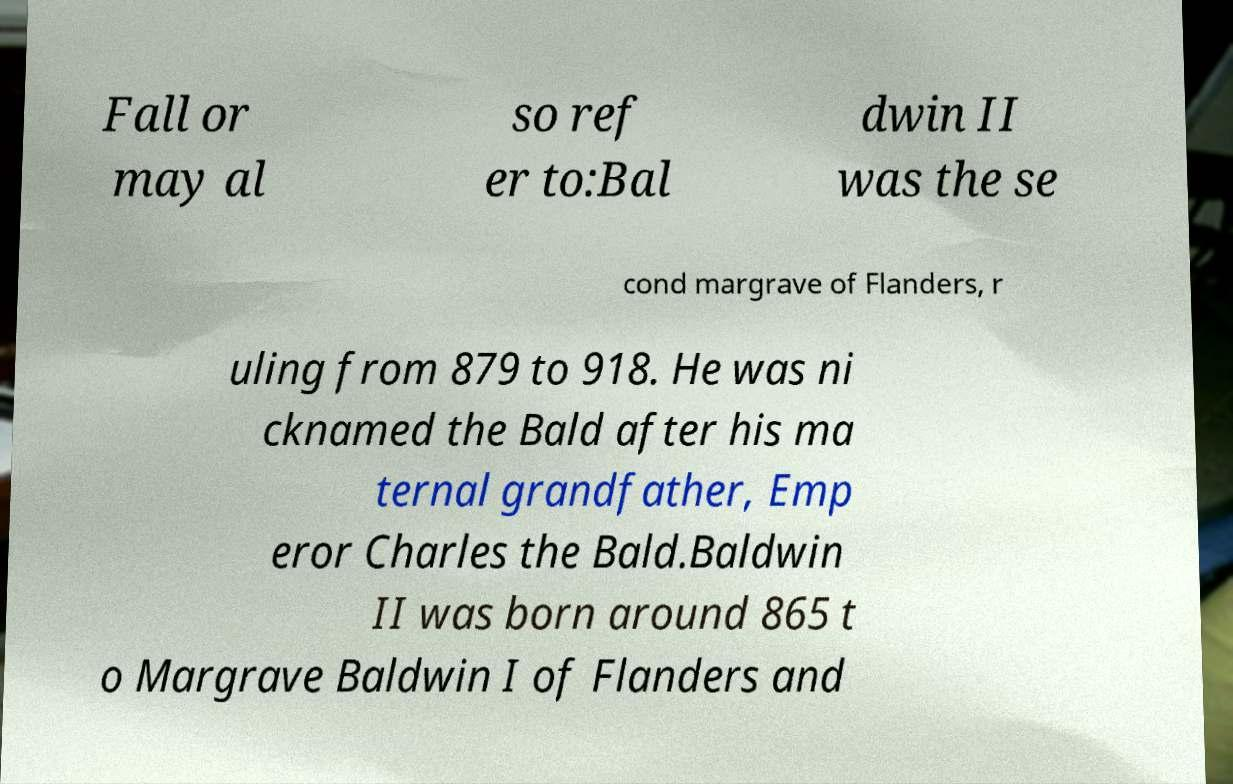For documentation purposes, I need the text within this image transcribed. Could you provide that? Fall or may al so ref er to:Bal dwin II was the se cond margrave of Flanders, r uling from 879 to 918. He was ni cknamed the Bald after his ma ternal grandfather, Emp eror Charles the Bald.Baldwin II was born around 865 t o Margrave Baldwin I of Flanders and 